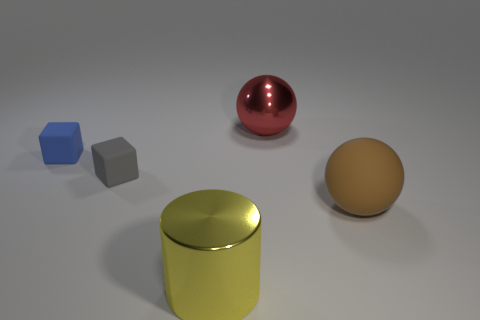Add 5 gray rubber things. How many objects exist? 10 Subtract all cubes. How many objects are left? 3 Add 2 big rubber spheres. How many big rubber spheres are left? 3 Add 1 large brown metal blocks. How many large brown metal blocks exist? 1 Subtract all blue blocks. How many blocks are left? 1 Subtract 0 green balls. How many objects are left? 5 Subtract 2 cubes. How many cubes are left? 0 Subtract all cyan blocks. Subtract all brown cylinders. How many blocks are left? 2 Subtract all big red shiny cubes. Subtract all tiny blue objects. How many objects are left? 4 